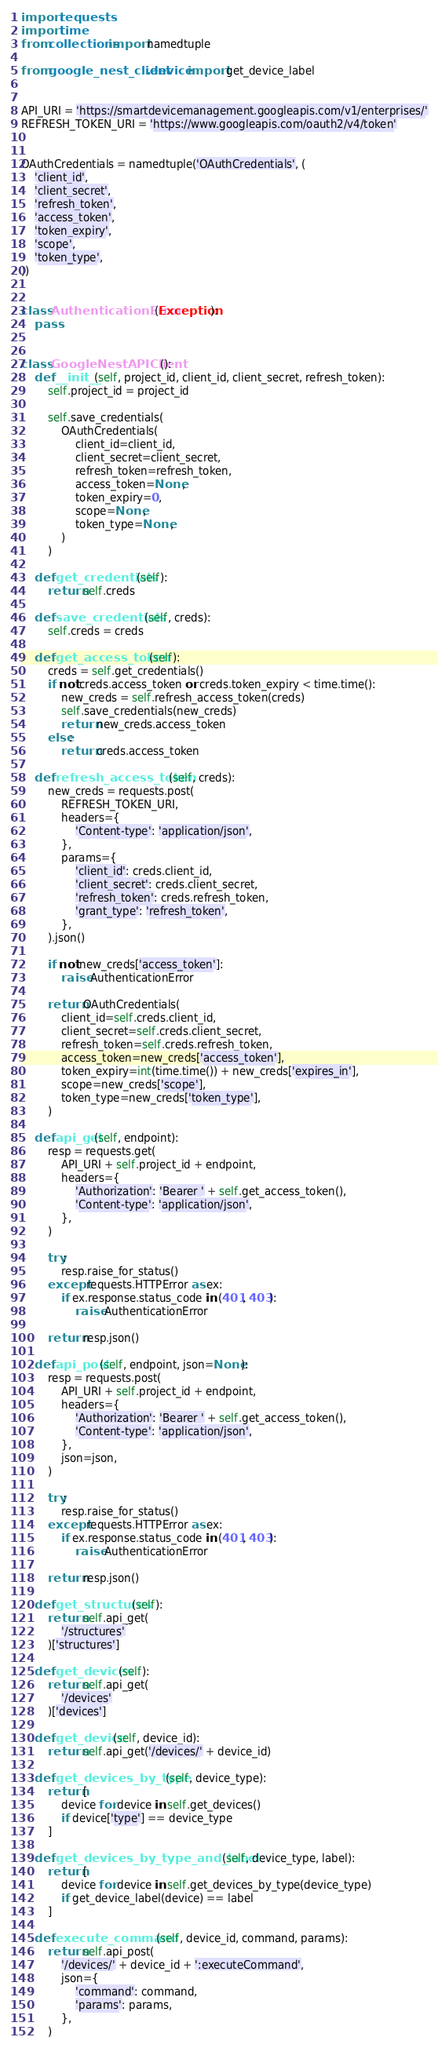Convert code to text. <code><loc_0><loc_0><loc_500><loc_500><_Python_>import requests
import time
from collections import namedtuple

from google_nest_client.device import get_device_label


API_URI = 'https://smartdevicemanagement.googleapis.com/v1/enterprises/'
REFRESH_TOKEN_URI = 'https://www.googleapis.com/oauth2/v4/token'


OAuthCredentials = namedtuple('OAuthCredentials', (
    'client_id',
    'client_secret',
    'refresh_token',
    'access_token',
    'token_expiry',
    'scope',
    'token_type',
))


class AuthenticationError(Exception):
    pass


class GoogleNestAPIClient():
    def __init__(self, project_id, client_id, client_secret, refresh_token):
        self.project_id = project_id

        self.save_credentials(
            OAuthCredentials(
                client_id=client_id,
                client_secret=client_secret,
                refresh_token=refresh_token,
                access_token=None,
                token_expiry=0,
                scope=None,
                token_type=None,
            )
        )

    def get_credentials(self):
        return self.creds

    def save_credentials(self, creds):
        self.creds = creds

    def get_access_token(self):
        creds = self.get_credentials()
        if not creds.access_token or creds.token_expiry < time.time():
            new_creds = self.refresh_access_token(creds)
            self.save_credentials(new_creds)
            return new_creds.access_token
        else:
            return creds.access_token

    def refresh_access_token(self, creds):
        new_creds = requests.post(
            REFRESH_TOKEN_URI,
            headers={
                'Content-type': 'application/json',
            },
            params={
                'client_id': creds.client_id,
                'client_secret': creds.client_secret,
                'refresh_token': creds.refresh_token,
                'grant_type': 'refresh_token',
            },
        ).json()

        if not new_creds['access_token']:
            raise AuthenticationError

        return OAuthCredentials(
            client_id=self.creds.client_id,
            client_secret=self.creds.client_secret,
            refresh_token=self.creds.refresh_token,
            access_token=new_creds['access_token'],
            token_expiry=int(time.time()) + new_creds['expires_in'],
            scope=new_creds['scope'],
            token_type=new_creds['token_type'],
        )

    def api_get(self, endpoint):
        resp = requests.get(
            API_URI + self.project_id + endpoint,
            headers={
                'Authorization': 'Bearer ' + self.get_access_token(),
                'Content-type': 'application/json',
            },
        )

        try:
            resp.raise_for_status()
        except requests.HTTPError as ex:
            if ex.response.status_code in (401, 403):
                raise AuthenticationError

        return resp.json()

    def api_post(self, endpoint, json=None):
        resp = requests.post(
            API_URI + self.project_id + endpoint,
            headers={
                'Authorization': 'Bearer ' + self.get_access_token(),
                'Content-type': 'application/json',
            },
            json=json,
        )

        try:
            resp.raise_for_status()
        except requests.HTTPError as ex:
            if ex.response.status_code in (401, 403):
                raise AuthenticationError

        return resp.json()

    def get_structures(self):
        return self.api_get(
            '/structures'
        )['structures']

    def get_devices(self):
        return self.api_get(
            '/devices'
        )['devices']

    def get_device(self, device_id):
        return self.api_get('/devices/' + device_id)

    def get_devices_by_type(self, device_type):
        return [
            device for device in self.get_devices()
            if device['type'] == device_type
        ]

    def get_devices_by_type_and_label(self, device_type, label):
        return [
            device for device in self.get_devices_by_type(device_type)
            if get_device_label(device) == label
        ]

    def execute_command(self, device_id, command, params):
        return self.api_post(
            '/devices/' + device_id + ':executeCommand',
            json={
                'command': command,
                'params': params,
            },
        )
</code> 